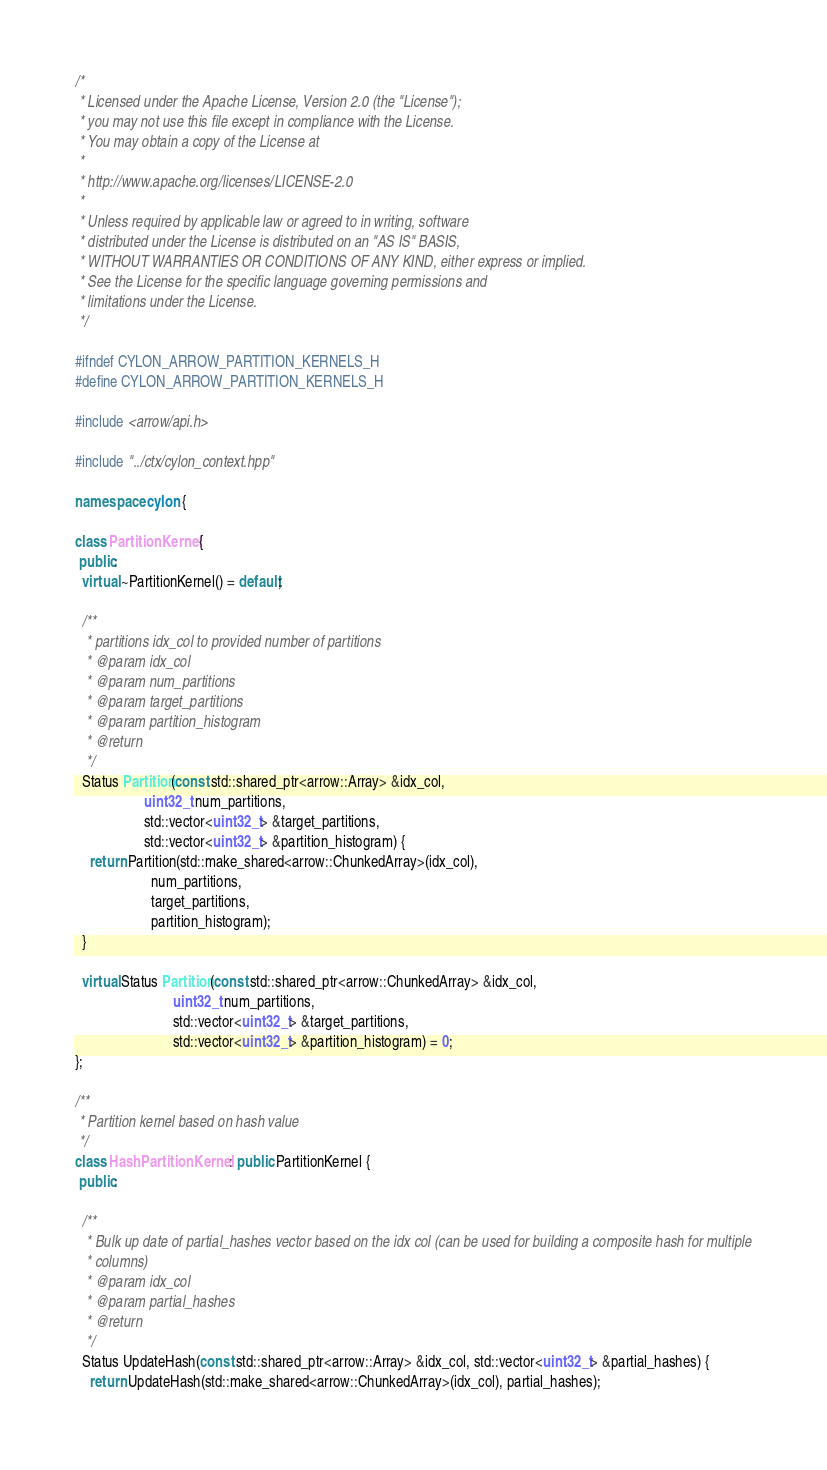Convert code to text. <code><loc_0><loc_0><loc_500><loc_500><_C++_>/*
 * Licensed under the Apache License, Version 2.0 (the "License");
 * you may not use this file except in compliance with the License.
 * You may obtain a copy of the License at
 *
 * http://www.apache.org/licenses/LICENSE-2.0
 *
 * Unless required by applicable law or agreed to in writing, software
 * distributed under the License is distributed on an "AS IS" BASIS,
 * WITHOUT WARRANTIES OR CONDITIONS OF ANY KIND, either express or implied.
 * See the License for the specific language governing permissions and
 * limitations under the License.
 */

#ifndef CYLON_ARROW_PARTITION_KERNELS_H
#define CYLON_ARROW_PARTITION_KERNELS_H

#include <arrow/api.h>

#include "../ctx/cylon_context.hpp"

namespace cylon {

class PartitionKernel {
 public:
  virtual ~PartitionKernel() = default;

  /**
   * partitions idx_col to provided number of partitions
   * @param idx_col
   * @param num_partitions
   * @param target_partitions
   * @param partition_histogram
   * @return
   */
  Status Partition(const std::shared_ptr<arrow::Array> &idx_col,
                   uint32_t num_partitions,
                   std::vector<uint32_t> &target_partitions,
                   std::vector<uint32_t> &partition_histogram) {
    return Partition(std::make_shared<arrow::ChunkedArray>(idx_col),
                     num_partitions,
                     target_partitions,
                     partition_histogram);
  }

  virtual Status Partition(const std::shared_ptr<arrow::ChunkedArray> &idx_col,
                           uint32_t num_partitions,
                           std::vector<uint32_t> &target_partitions,
                           std::vector<uint32_t> &partition_histogram) = 0;
};

/**
 * Partition kernel based on hash value
 */
class HashPartitionKernel : public PartitionKernel {
 public:

  /**
   * Bulk up date of partial_hashes vector based on the idx col (can be used for building a composite hash for multiple
   * columns)
   * @param idx_col
   * @param partial_hashes
   * @return
   */
  Status UpdateHash(const std::shared_ptr<arrow::Array> &idx_col, std::vector<uint32_t> &partial_hashes) {
    return UpdateHash(std::make_shared<arrow::ChunkedArray>(idx_col), partial_hashes);</code> 